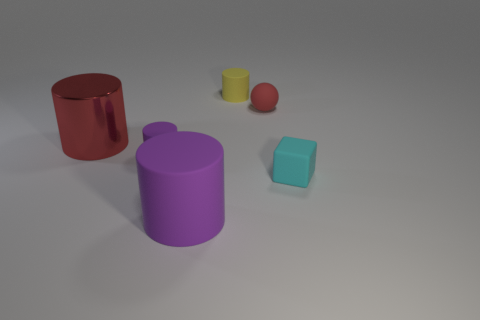Are there fewer cylinders than small cubes?
Your answer should be compact. No. Is the material of the yellow cylinder the same as the small sphere?
Keep it short and to the point. Yes. How many other things are the same size as the cyan object?
Offer a very short reply. 3. There is a large thing behind the purple cylinder that is behind the big purple rubber cylinder; what color is it?
Your answer should be compact. Red. What number of other things are there of the same shape as the big rubber object?
Your answer should be compact. 3. Are there any other cylinders that have the same material as the red cylinder?
Give a very brief answer. No. There is a thing that is the same size as the red cylinder; what is it made of?
Provide a short and direct response. Rubber. There is a small rubber object to the right of the red object on the right side of the purple matte cylinder that is in front of the cyan matte object; what color is it?
Keep it short and to the point. Cyan. Does the tiny object left of the small yellow cylinder have the same shape as the large object that is behind the rubber block?
Offer a terse response. Yes. What number of big gray blocks are there?
Provide a succinct answer. 0. 